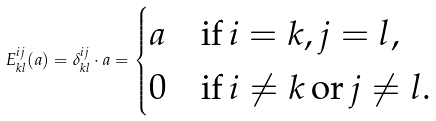<formula> <loc_0><loc_0><loc_500><loc_500>E ^ { i j } _ { k l } ( a ) = \delta _ { k l } ^ { i j } \cdot a = \begin{cases} a & \text {if} \, i = k , j = l , \\ 0 & \text {if} \, i \neq k \, \text {or} \, j \neq l . \end{cases}</formula> 